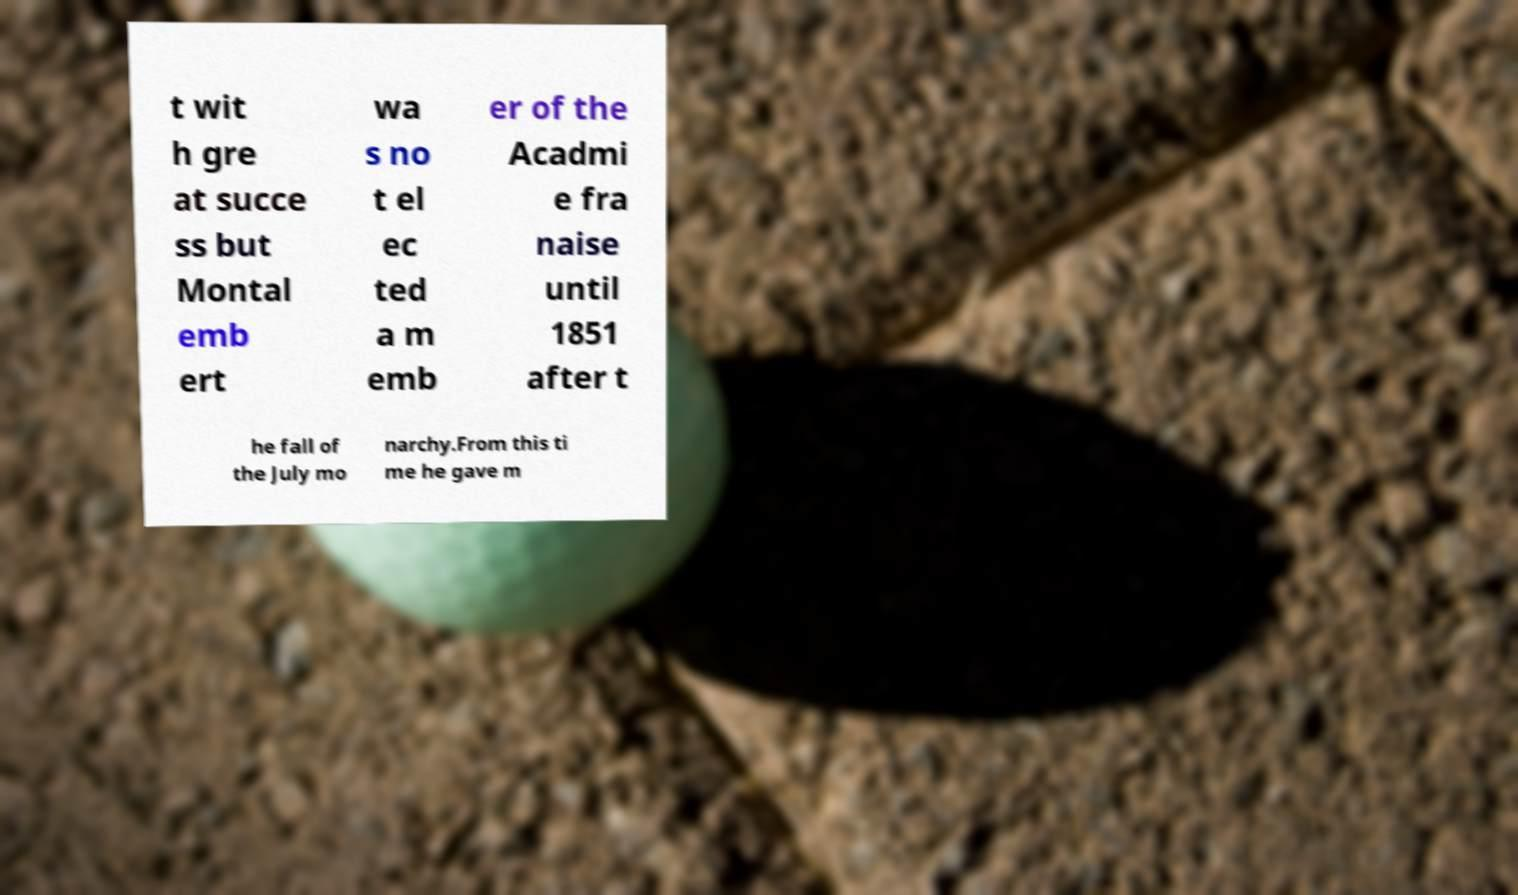There's text embedded in this image that I need extracted. Can you transcribe it verbatim? t wit h gre at succe ss but Montal emb ert wa s no t el ec ted a m emb er of the Acadmi e fra naise until 1851 after t he fall of the July mo narchy.From this ti me he gave m 